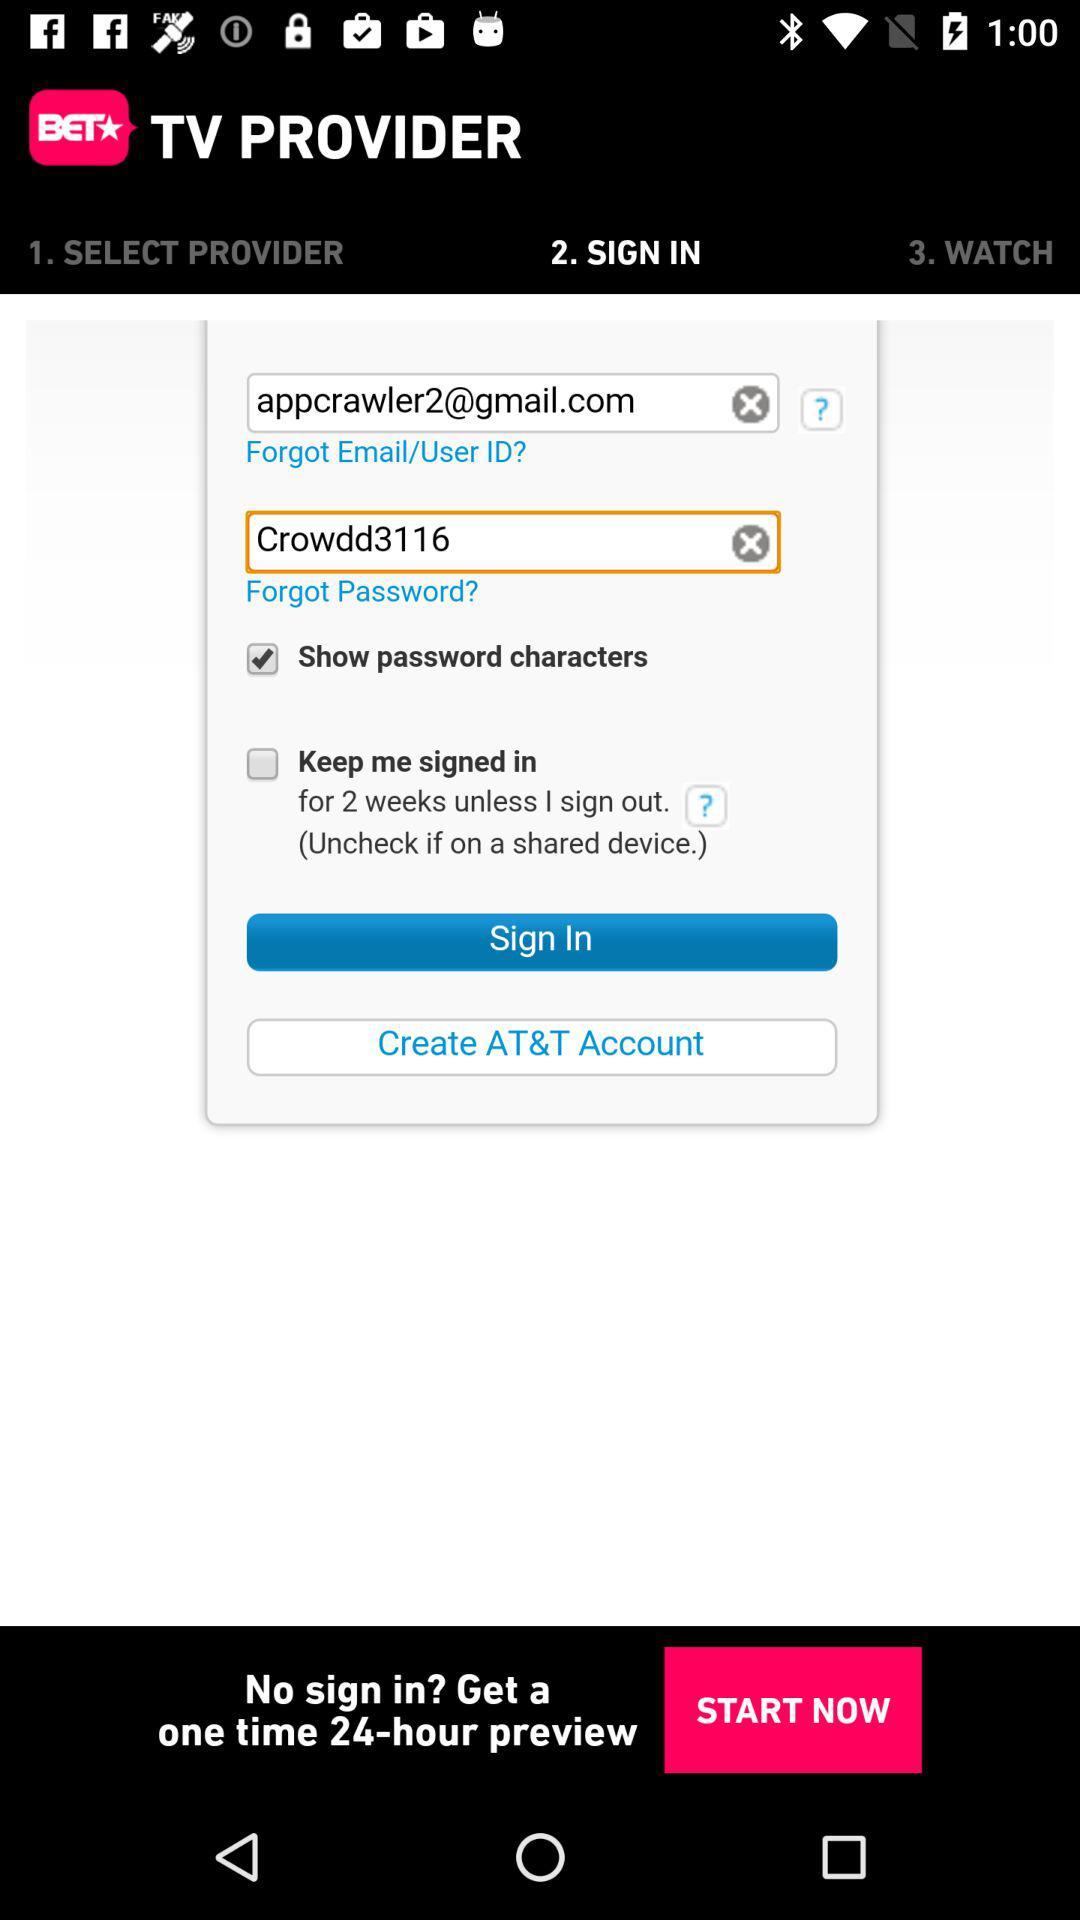What is the application name? The application name is "BET NOW". 